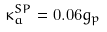Convert formula to latex. <formula><loc_0><loc_0><loc_500><loc_500>\kappa ^ { S P } _ { a } = 0 . 0 6 g _ { p }</formula> 